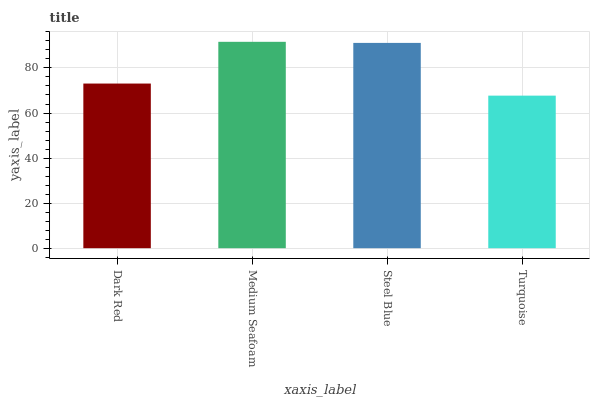Is Turquoise the minimum?
Answer yes or no. Yes. Is Medium Seafoam the maximum?
Answer yes or no. Yes. Is Steel Blue the minimum?
Answer yes or no. No. Is Steel Blue the maximum?
Answer yes or no. No. Is Medium Seafoam greater than Steel Blue?
Answer yes or no. Yes. Is Steel Blue less than Medium Seafoam?
Answer yes or no. Yes. Is Steel Blue greater than Medium Seafoam?
Answer yes or no. No. Is Medium Seafoam less than Steel Blue?
Answer yes or no. No. Is Steel Blue the high median?
Answer yes or no. Yes. Is Dark Red the low median?
Answer yes or no. Yes. Is Dark Red the high median?
Answer yes or no. No. Is Steel Blue the low median?
Answer yes or no. No. 